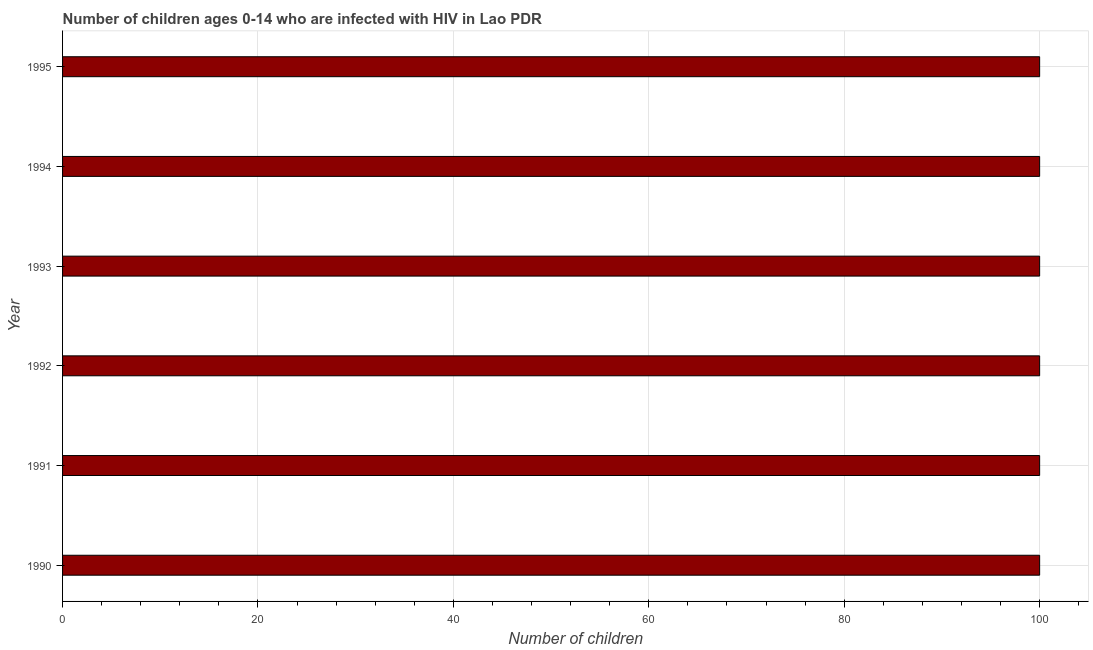What is the title of the graph?
Ensure brevity in your answer.  Number of children ages 0-14 who are infected with HIV in Lao PDR. What is the label or title of the X-axis?
Provide a succinct answer. Number of children. What is the number of children living with hiv in 1992?
Your response must be concise. 100. In which year was the number of children living with hiv maximum?
Make the answer very short. 1990. In which year was the number of children living with hiv minimum?
Your answer should be very brief. 1990. What is the sum of the number of children living with hiv?
Provide a short and direct response. 600. What is the difference between the number of children living with hiv in 1990 and 1992?
Ensure brevity in your answer.  0. What is the median number of children living with hiv?
Offer a terse response. 100. In how many years, is the number of children living with hiv greater than 24 ?
Make the answer very short. 6. What is the difference between the highest and the second highest number of children living with hiv?
Provide a short and direct response. 0. Is the sum of the number of children living with hiv in 1991 and 1994 greater than the maximum number of children living with hiv across all years?
Ensure brevity in your answer.  Yes. What is the difference between the highest and the lowest number of children living with hiv?
Make the answer very short. 0. How many years are there in the graph?
Provide a succinct answer. 6. What is the Number of children of 1990?
Your answer should be compact. 100. What is the Number of children in 1995?
Your response must be concise. 100. What is the difference between the Number of children in 1990 and 1991?
Your response must be concise. 0. What is the difference between the Number of children in 1990 and 1993?
Offer a terse response. 0. What is the difference between the Number of children in 1991 and 1994?
Make the answer very short. 0. What is the difference between the Number of children in 1992 and 1993?
Provide a succinct answer. 0. What is the difference between the Number of children in 1993 and 1994?
Your answer should be very brief. 0. What is the difference between the Number of children in 1993 and 1995?
Provide a succinct answer. 0. What is the difference between the Number of children in 1994 and 1995?
Your answer should be compact. 0. What is the ratio of the Number of children in 1990 to that in 1993?
Ensure brevity in your answer.  1. What is the ratio of the Number of children in 1991 to that in 1993?
Provide a short and direct response. 1. What is the ratio of the Number of children in 1991 to that in 1995?
Offer a very short reply. 1. What is the ratio of the Number of children in 1992 to that in 1993?
Keep it short and to the point. 1. What is the ratio of the Number of children in 1992 to that in 1995?
Offer a very short reply. 1. What is the ratio of the Number of children in 1993 to that in 1994?
Make the answer very short. 1. What is the ratio of the Number of children in 1993 to that in 1995?
Your answer should be very brief. 1. What is the ratio of the Number of children in 1994 to that in 1995?
Ensure brevity in your answer.  1. 